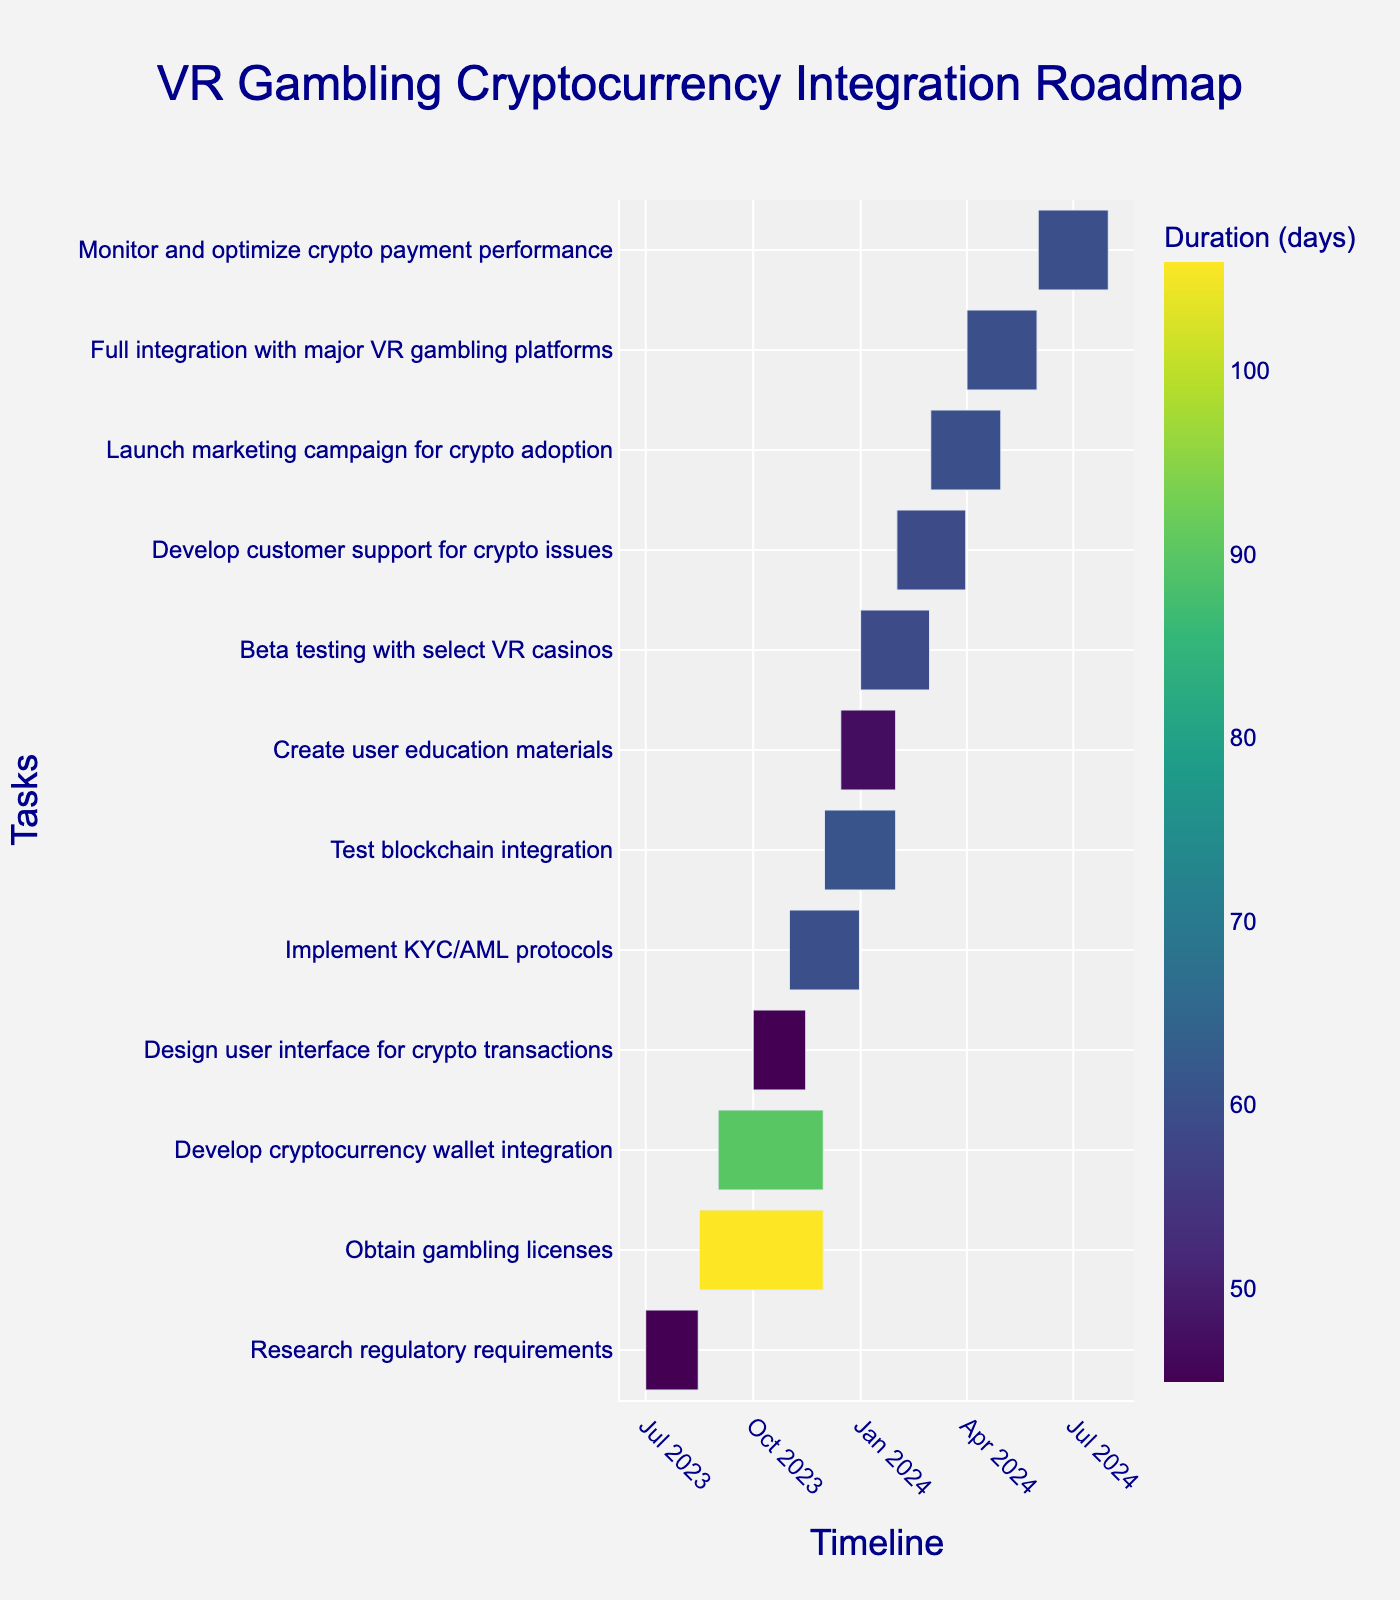What is the title of the Gantt chart? The title of a Gantt chart is usually found at the top of the figure and concisely describes what the chart is about.
Answer: VR Gambling Cryptocurrency Integration Roadmap Which task has the shortest duration? To determine the shortest duration, look for the task bar with the smallest length on the timeline. Compare the duration labels next to each bar.
Answer: Research regulatory requirements (45 days) Which two tasks overlap in December 2023? Check the Gantt chart for tasks that have bars extending into December 2023. Identify the ones that share the same time period.
Answer: Implement KYC/AML protocols and Test blockchain integration How many tasks are scheduled to end by November 30, 2023? Look at the end dates for each task and count how many have November 30, 2023, or earlier as their end date.
Answer: Three tasks What is the total duration for 'Test blockchain integration' and 'Create user education materials'? Identify the duration of each task and sum them up. 'Test blockchain integration' lasts for 61 days and 'Create user education materials' lasts for 47 days. Adding them together gives the total duration.
Answer: 108 days Which task has the longest duration? Check the durations of each task and find the one with the highest value.
Answer: Obtain gambling licenses (106 days) When does 'Beta testing with select VR casinos' start and end? Locate the 'Beta testing with select VR casinos' task in the timeline. Refer to its start and end dates labeled on the chart.
Answer: Starts on January 1, 2024, and ends on February 29, 2024 What's the combined duration of all tasks related to regulatory compliance? Identify the tasks associated with regulatory compliance (e.g. ‘Research regulatory requirements’, ‘Obtain gambling licenses’, ‘Implement KYC/AML protocols’). Sum up their individual durations.
Answer: 211 days Are there any tasks that start in 2024? If yes, name them. Look for the bars that begin in 2024 on the timeline. Identify and list the names of these tasks.
Answer: Yes, ‘Beta testing with select VR casinos’, ‘Develop customer support for crypto issues’, ‘Launch marketing campaign for crypto adoption’, ‘Full integration with major VR gambling platforms’, ‘Monitor and optimize crypto payment performance’ Which task starts right after 'Develop cryptocurrency wallet integration' ends? Check the end date of 'Develop cryptocurrency wallet integration', then see which task starts immediately after this date.
Answer: Implement KYC/AML protocols 